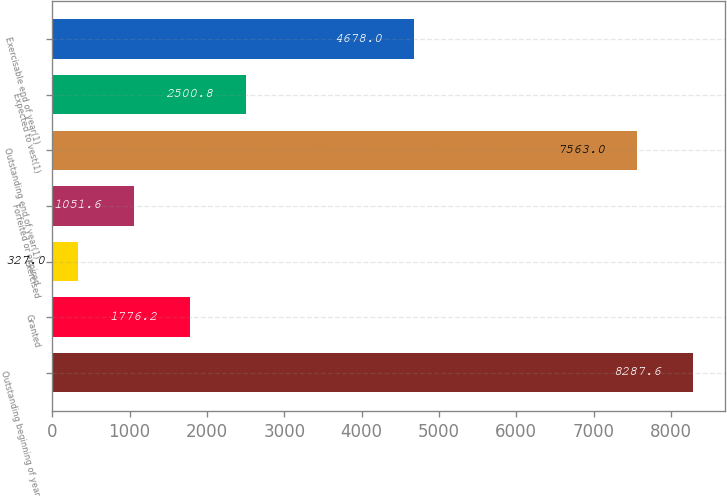Convert chart. <chart><loc_0><loc_0><loc_500><loc_500><bar_chart><fcel>Outstanding beginning of year<fcel>Granted<fcel>Exercised<fcel>Forfeited or expired<fcel>Outstanding end of year(1)<fcel>Expected to vest(1)<fcel>Exercisable end of year(1)<nl><fcel>8287.6<fcel>1776.2<fcel>327<fcel>1051.6<fcel>7563<fcel>2500.8<fcel>4678<nl></chart> 